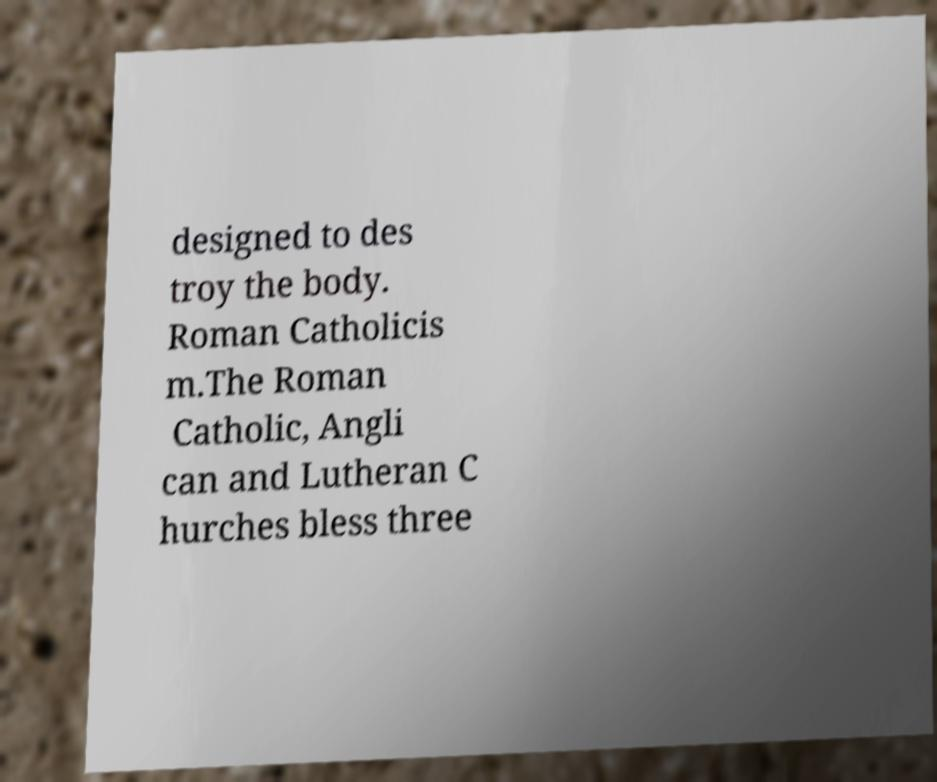I need the written content from this picture converted into text. Can you do that? designed to des troy the body. Roman Catholicis m.The Roman Catholic, Angli can and Lutheran C hurches bless three 